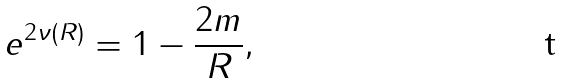<formula> <loc_0><loc_0><loc_500><loc_500>e ^ { 2 \nu ( R ) } = 1 - \frac { 2 m } { R } ,</formula> 